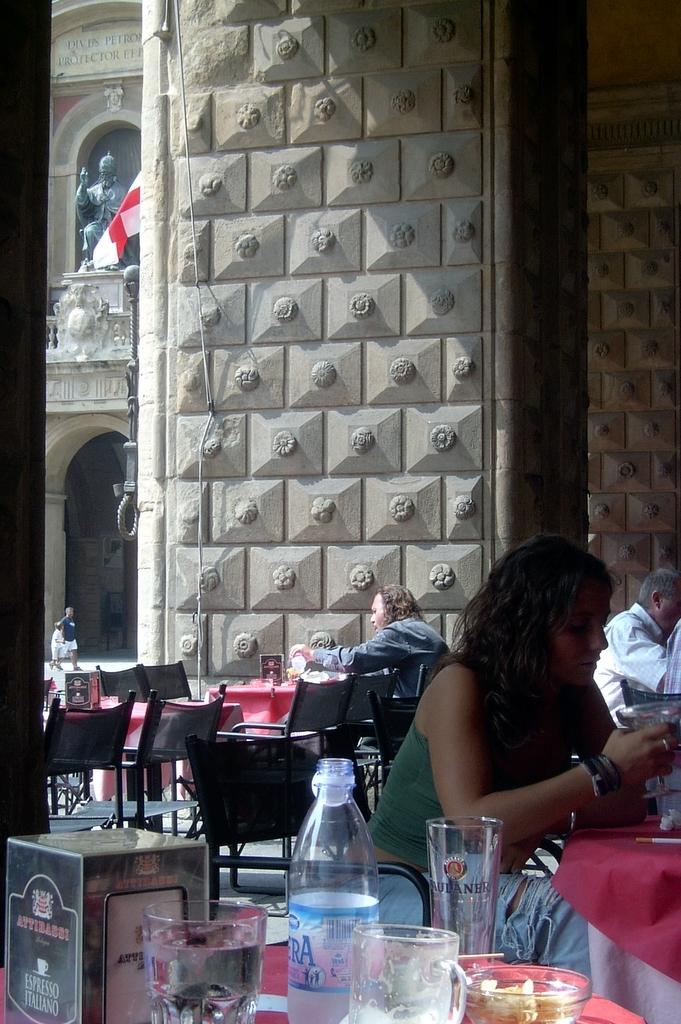What type of space is depicted in the image? There is a room in the image. What furniture can be seen in the room? The room contains chairs and tables. How many people are in the room? There is a crowd in the room. What is located on the first floor of the room? There is a sculpture on the first floor of the room. What is hanging in front of the sculpture? A flag is hanging in front of the sculpture. What type of match is being played in the room? There is no match being played in the room; the image does not depict any sports or games. 